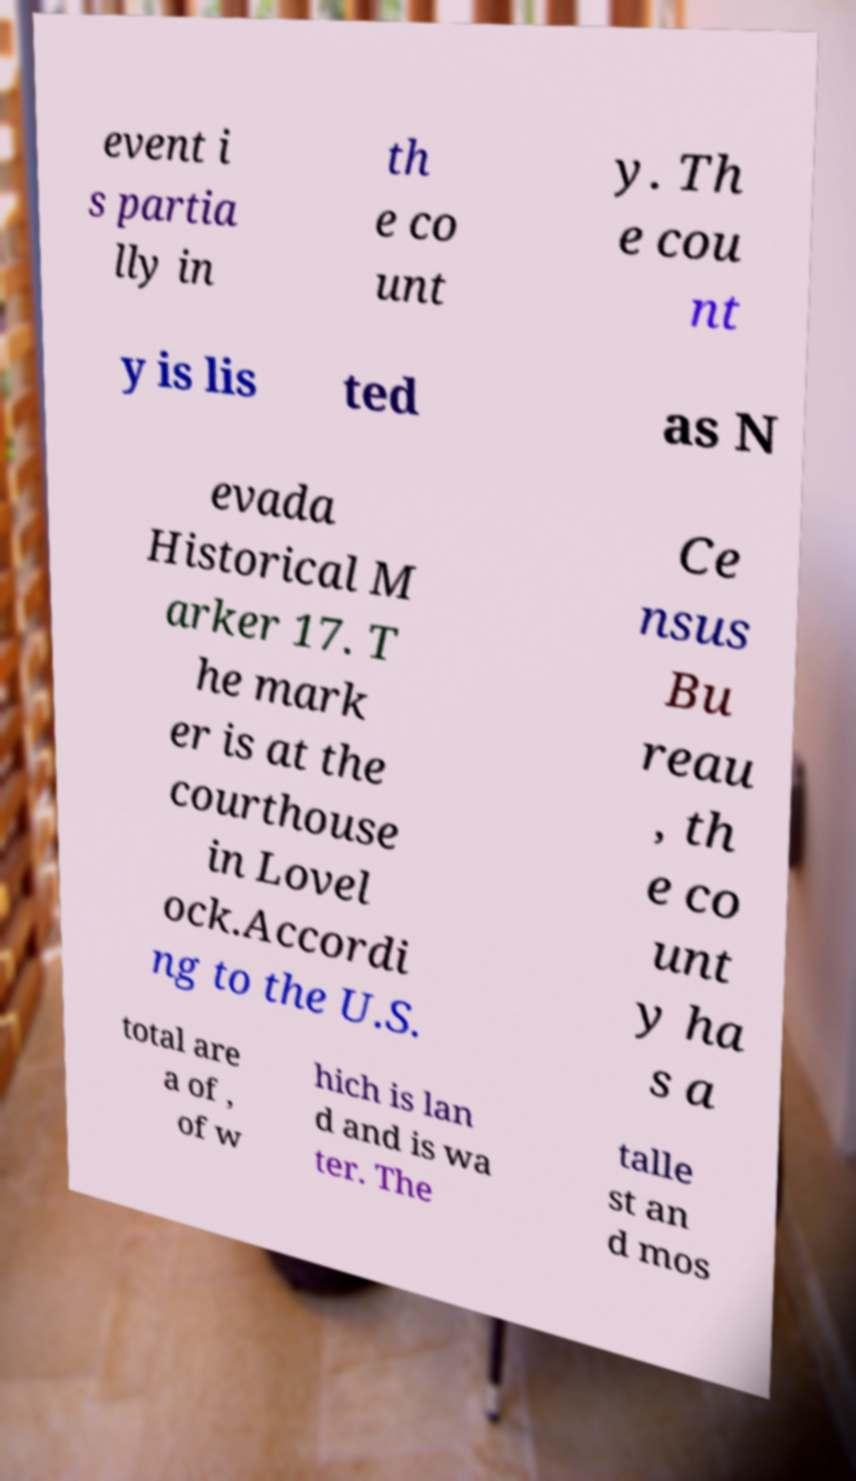Could you assist in decoding the text presented in this image and type it out clearly? event i s partia lly in th e co unt y. Th e cou nt y is lis ted as N evada Historical M arker 17. T he mark er is at the courthouse in Lovel ock.Accordi ng to the U.S. Ce nsus Bu reau , th e co unt y ha s a total are a of , of w hich is lan d and is wa ter. The talle st an d mos 